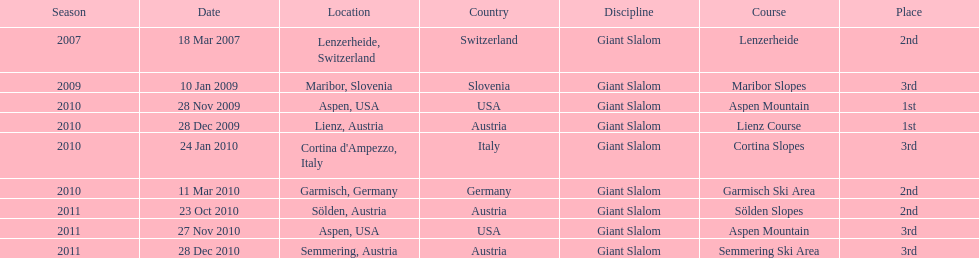Where was her first win? Aspen, USA. 